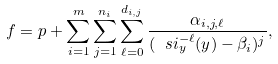<formula> <loc_0><loc_0><loc_500><loc_500>f = p + \sum _ { i = 1 } ^ { m } \sum _ { j = 1 } ^ { n _ { i } } \sum _ { \ell = 0 } ^ { d _ { i , j } } \frac { \alpha _ { i , j , \ell } } { ( \ s i _ { y } ^ { - \ell } ( y ) - \beta _ { i } ) ^ { j } } ,</formula> 